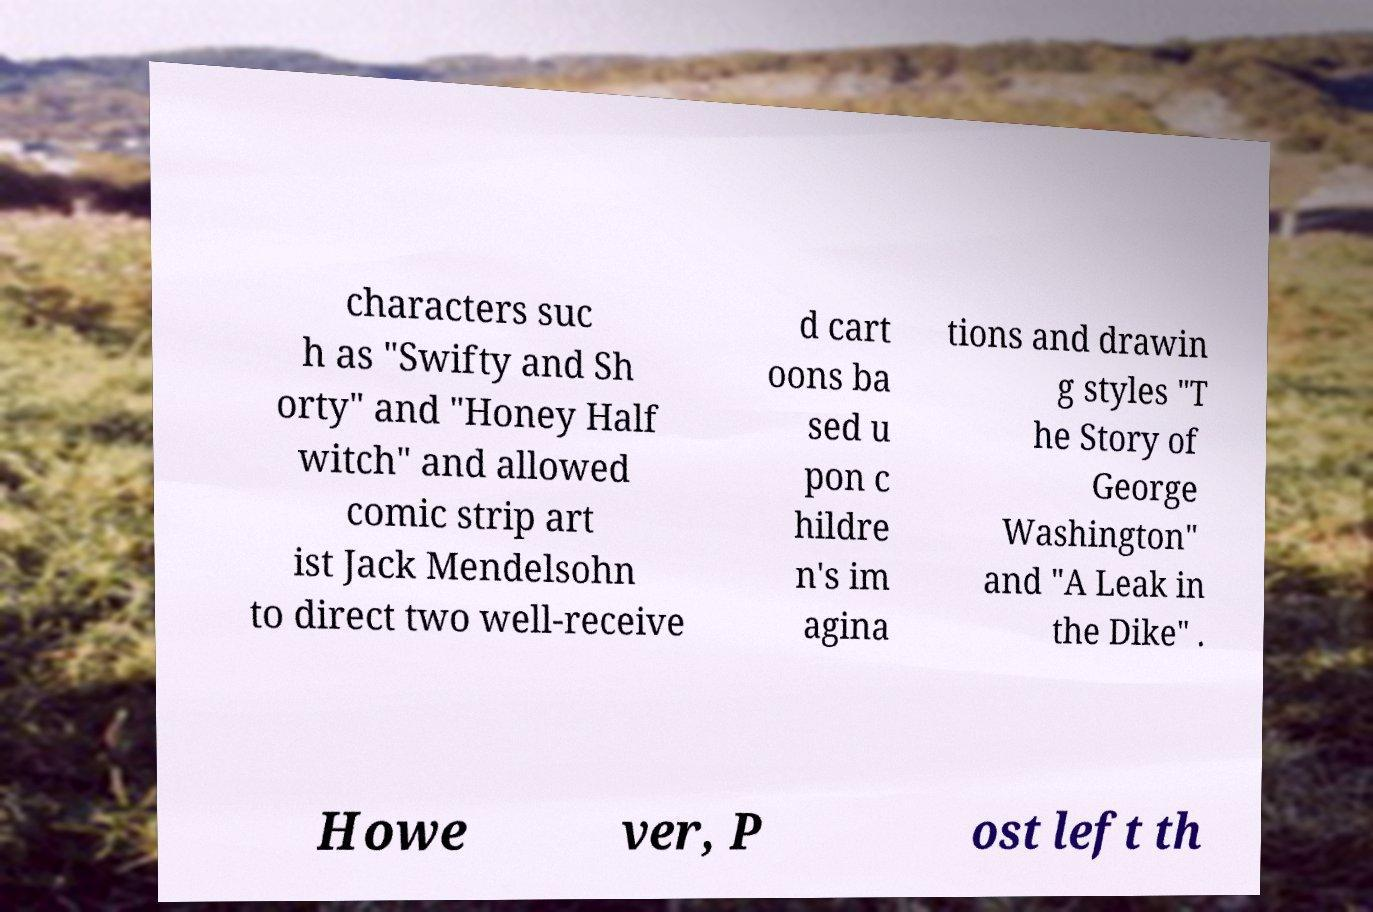What messages or text are displayed in this image? I need them in a readable, typed format. characters suc h as "Swifty and Sh orty" and "Honey Half witch" and allowed comic strip art ist Jack Mendelsohn to direct two well-receive d cart oons ba sed u pon c hildre n's im agina tions and drawin g styles "T he Story of George Washington" and "A Leak in the Dike" . Howe ver, P ost left th 